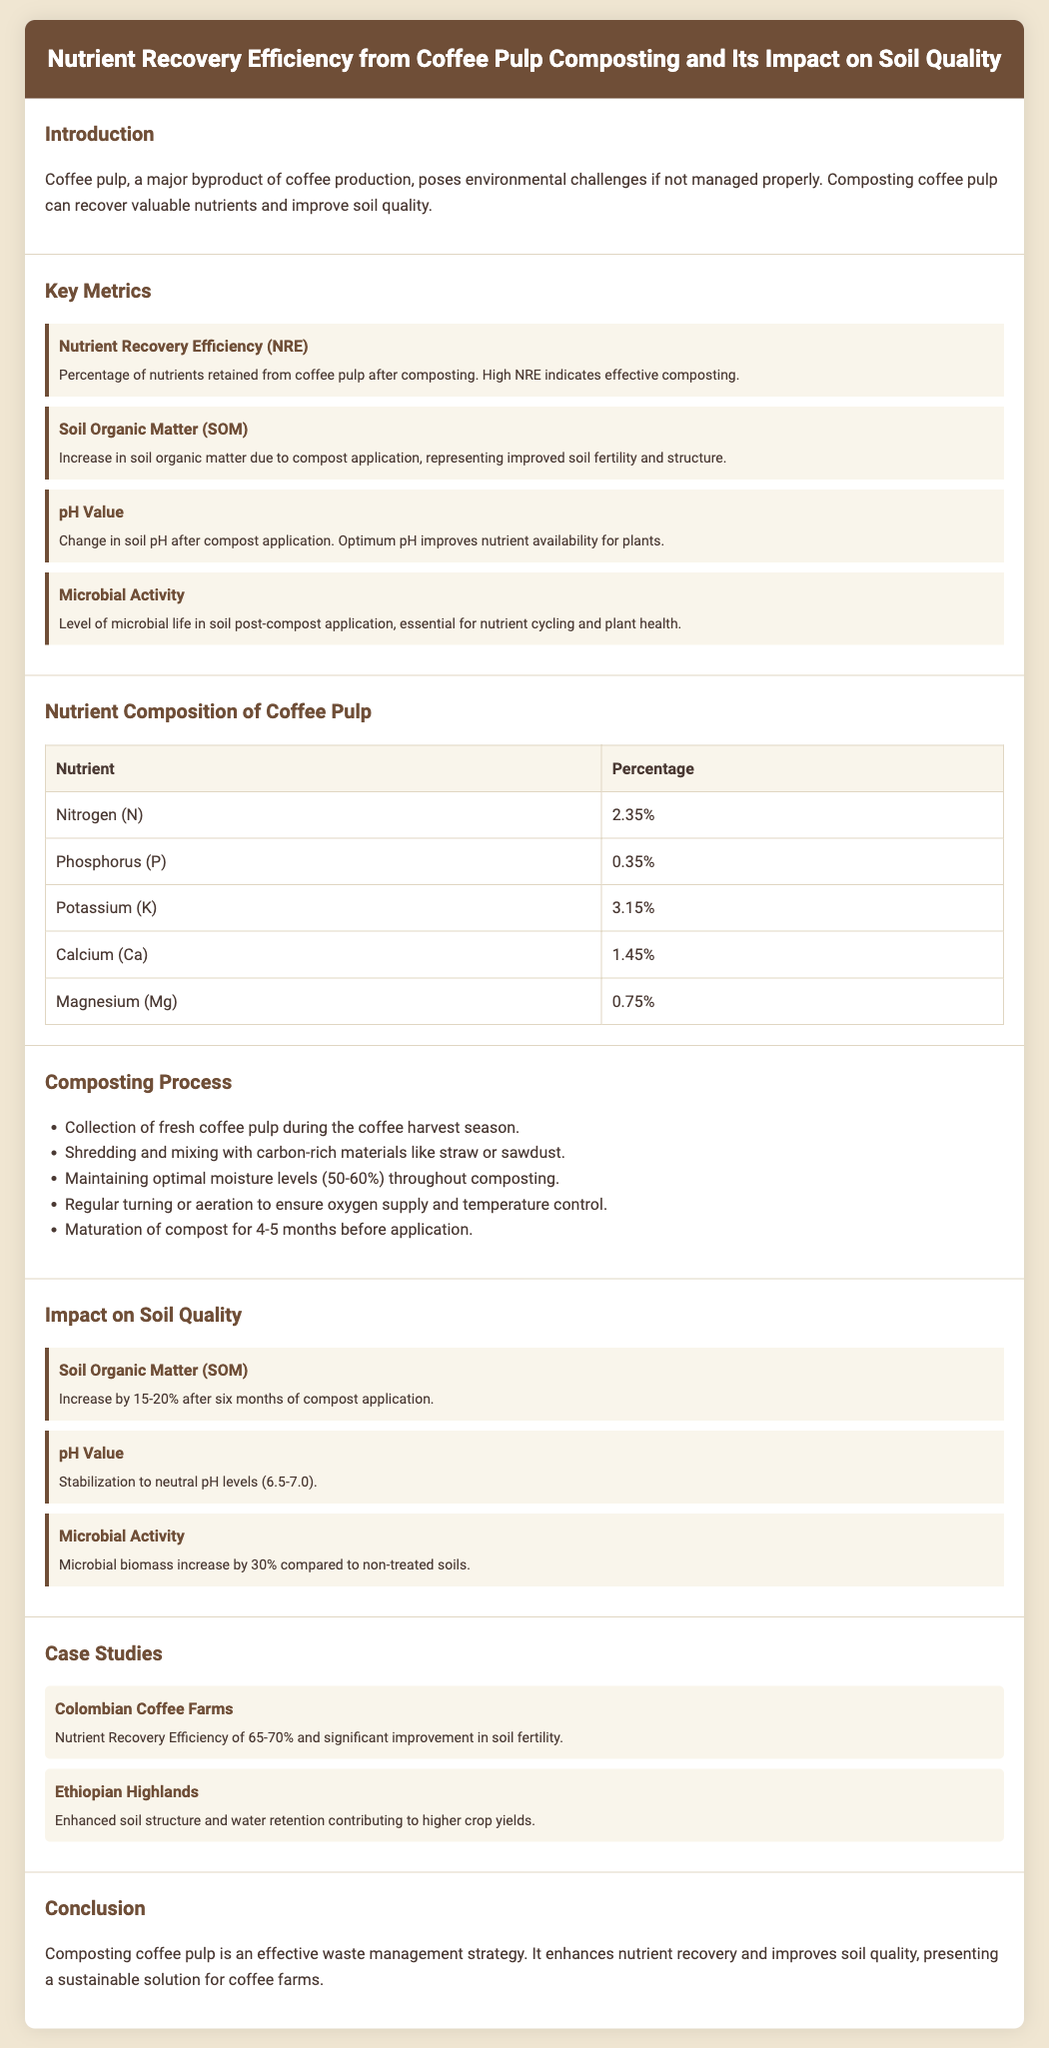what is the Nutrient Recovery Efficiency (NRE)? The Nutrient Recovery Efficiency (NRE) is defined as the percentage of nutrients retained from coffee pulp after composting.
Answer: Percentage of nutrients retained from coffee pulp how much was the increase in Soil Organic Matter (SOM)? The Soil Organic Matter (SOM) increased by 15-20% after six months of compost application.
Answer: 15-20% what is the pH value stabilization range after compost application? The pH value stabilized to neutral levels after compost application.
Answer: 6.5-7.0 what is the percentage of Nitrogen in coffee pulp? The document states that the percentage of Nitrogen (N) present in coffee pulp is listed in a table.
Answer: 2.35% how long does the composting process take before application? The compost must mature for 4-5 months before it can be applied to the soil.
Answer: 4-5 months which case study reported a Nutrient Recovery Efficiency of 65-70%? The case study mentioning a Nutrient Recovery Efficiency of 65-70% involves Colombian Coffee Farms.
Answer: Colombian Coffee Farms what impact does compost application have on microbial biomass? The compost application resulted in a microbial biomass increase compared to non-treated soils.
Answer: Increase by 30% what is the carbon-rich material suggested for mixing with coffee pulp? The document refers to straw or sawdust as carbon-rich materials to mix with coffee pulp.
Answer: Straw or sawdust how many nutrients are listed in the Nutrient Composition of Coffee Pulp table? The table in the document lists different nutrients and their percentages.
Answer: Five nutrients 